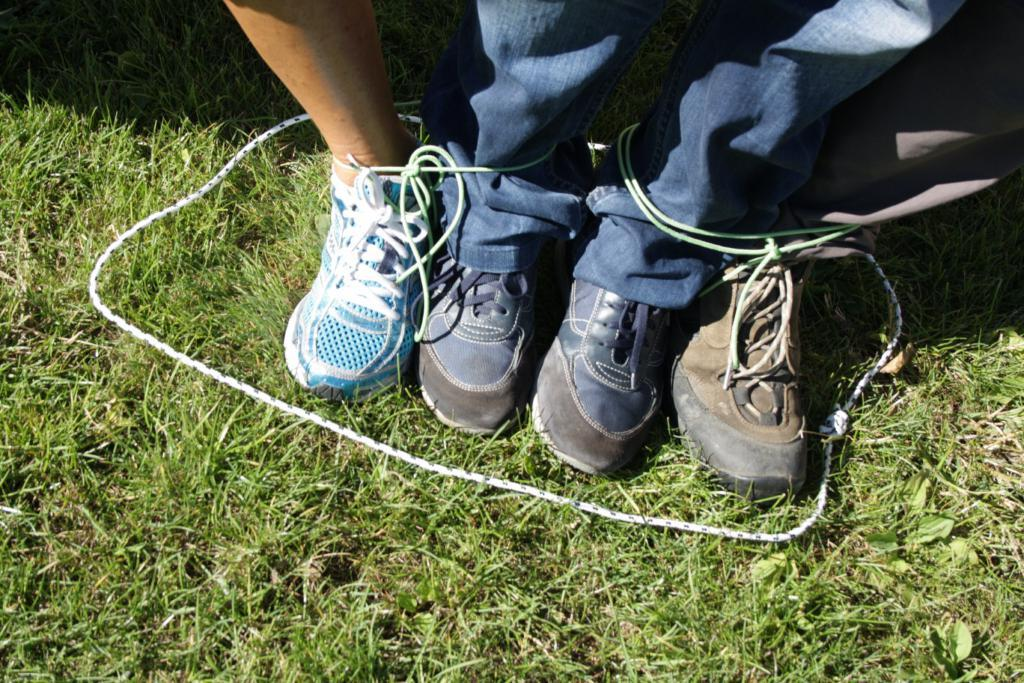What type of vegetation can be seen in the image? There is grass in the image. What object is present that could be used for various purposes? There is a rope in the image. What type of footwear is visible in the image? There are shoes in the image. Whose legs can be seen in the image? There are people's legs visible in the image. How many roses are present in the image? There are no roses present in the image. What type of beast can be seen in the image? There is no beast present in the image. 